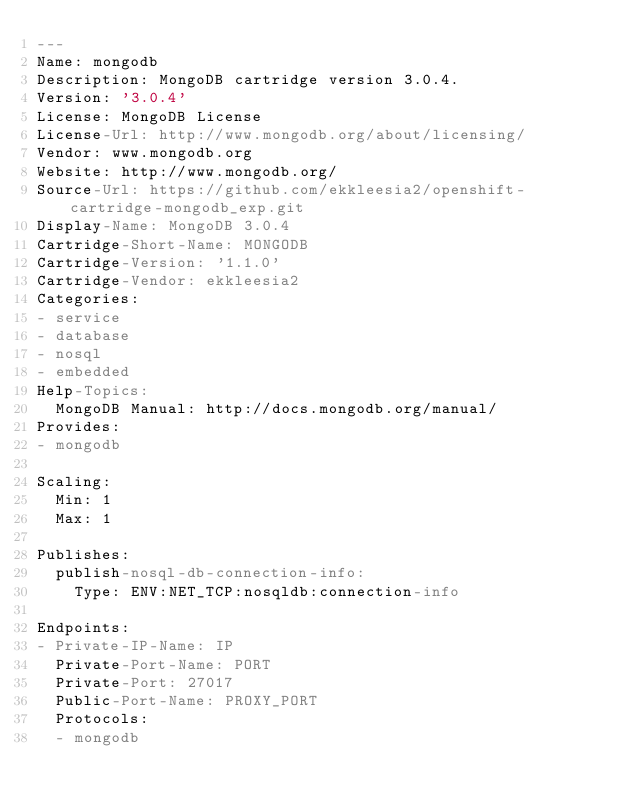Convert code to text. <code><loc_0><loc_0><loc_500><loc_500><_YAML_>---
Name: mongodb
Description: MongoDB cartridge version 3.0.4.
Version: '3.0.4'
License: MongoDB License
License-Url: http://www.mongodb.org/about/licensing/
Vendor: www.mongodb.org
Website: http://www.mongodb.org/
Source-Url: https://github.com/ekkleesia2/openshift-cartridge-mongodb_exp.git
Display-Name: MongoDB 3.0.4
Cartridge-Short-Name: MONGODB
Cartridge-Version: '1.1.0'
Cartridge-Vendor: ekkleesia2
Categories:
- service
- database
- nosql
- embedded
Help-Topics:
  MongoDB Manual: http://docs.mongodb.org/manual/
Provides:
- mongodb

Scaling:
  Min: 1
  Max: 1

Publishes:
  publish-nosql-db-connection-info:
    Type: ENV:NET_TCP:nosqldb:connection-info

Endpoints:
- Private-IP-Name: IP
  Private-Port-Name: PORT
  Private-Port: 27017
  Public-Port-Name: PROXY_PORT
  Protocols:
  - mongodb
</code> 